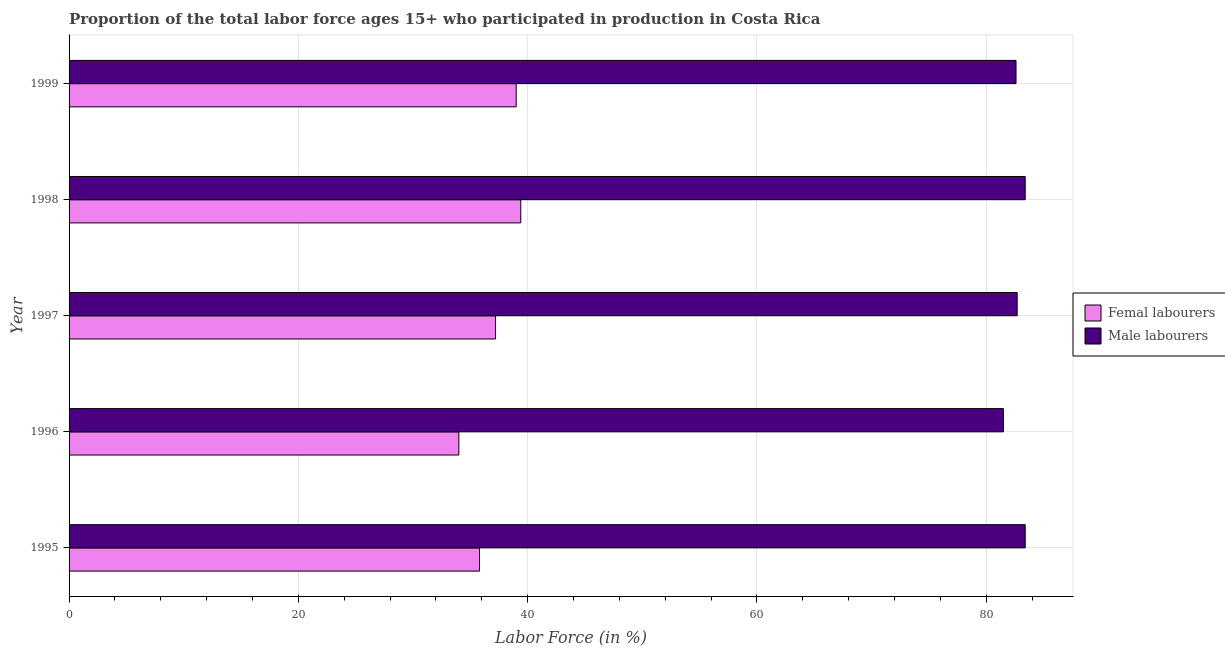How many groups of bars are there?
Make the answer very short. 5. Are the number of bars per tick equal to the number of legend labels?
Ensure brevity in your answer.  Yes. Are the number of bars on each tick of the Y-axis equal?
Keep it short and to the point. Yes. How many bars are there on the 5th tick from the top?
Give a very brief answer. 2. How many bars are there on the 5th tick from the bottom?
Ensure brevity in your answer.  2. What is the label of the 2nd group of bars from the top?
Your response must be concise. 1998. What is the percentage of male labour force in 1998?
Provide a succinct answer. 83.4. Across all years, what is the maximum percentage of female labor force?
Offer a terse response. 39.4. Across all years, what is the minimum percentage of female labor force?
Offer a terse response. 34. In which year was the percentage of female labor force maximum?
Ensure brevity in your answer.  1998. What is the total percentage of male labour force in the graph?
Provide a short and direct response. 413.6. What is the difference between the percentage of female labor force in 1995 and the percentage of male labour force in 1998?
Offer a very short reply. -47.6. What is the average percentage of male labour force per year?
Keep it short and to the point. 82.72. In the year 1996, what is the difference between the percentage of female labor force and percentage of male labour force?
Give a very brief answer. -47.5. What is the ratio of the percentage of female labor force in 1996 to that in 1998?
Make the answer very short. 0.86. Is the percentage of female labor force in 1996 less than that in 1999?
Keep it short and to the point. Yes. What does the 1st bar from the top in 1999 represents?
Your response must be concise. Male labourers. What does the 1st bar from the bottom in 1997 represents?
Provide a short and direct response. Femal labourers. Are all the bars in the graph horizontal?
Offer a terse response. Yes. Does the graph contain grids?
Provide a short and direct response. Yes. How many legend labels are there?
Keep it short and to the point. 2. How are the legend labels stacked?
Make the answer very short. Vertical. What is the title of the graph?
Make the answer very short. Proportion of the total labor force ages 15+ who participated in production in Costa Rica. Does "Automatic Teller Machines" appear as one of the legend labels in the graph?
Provide a succinct answer. No. What is the label or title of the X-axis?
Your response must be concise. Labor Force (in %). What is the label or title of the Y-axis?
Give a very brief answer. Year. What is the Labor Force (in %) in Femal labourers in 1995?
Your answer should be compact. 35.8. What is the Labor Force (in %) of Male labourers in 1995?
Make the answer very short. 83.4. What is the Labor Force (in %) in Male labourers in 1996?
Provide a succinct answer. 81.5. What is the Labor Force (in %) of Femal labourers in 1997?
Your response must be concise. 37.2. What is the Labor Force (in %) of Male labourers in 1997?
Provide a short and direct response. 82.7. What is the Labor Force (in %) of Femal labourers in 1998?
Make the answer very short. 39.4. What is the Labor Force (in %) in Male labourers in 1998?
Offer a very short reply. 83.4. What is the Labor Force (in %) in Femal labourers in 1999?
Provide a succinct answer. 39. What is the Labor Force (in %) of Male labourers in 1999?
Give a very brief answer. 82.6. Across all years, what is the maximum Labor Force (in %) in Femal labourers?
Provide a short and direct response. 39.4. Across all years, what is the maximum Labor Force (in %) of Male labourers?
Your response must be concise. 83.4. Across all years, what is the minimum Labor Force (in %) of Male labourers?
Offer a terse response. 81.5. What is the total Labor Force (in %) of Femal labourers in the graph?
Offer a very short reply. 185.4. What is the total Labor Force (in %) in Male labourers in the graph?
Make the answer very short. 413.6. What is the difference between the Labor Force (in %) of Femal labourers in 1995 and that in 1996?
Offer a terse response. 1.8. What is the difference between the Labor Force (in %) of Male labourers in 1995 and that in 1996?
Your response must be concise. 1.9. What is the difference between the Labor Force (in %) of Femal labourers in 1995 and that in 1999?
Make the answer very short. -3.2. What is the difference between the Labor Force (in %) of Femal labourers in 1996 and that in 1998?
Your answer should be compact. -5.4. What is the difference between the Labor Force (in %) in Male labourers in 1996 and that in 1998?
Offer a terse response. -1.9. What is the difference between the Labor Force (in %) of Femal labourers in 1996 and that in 1999?
Keep it short and to the point. -5. What is the difference between the Labor Force (in %) in Male labourers in 1997 and that in 1998?
Ensure brevity in your answer.  -0.7. What is the difference between the Labor Force (in %) in Male labourers in 1997 and that in 1999?
Provide a succinct answer. 0.1. What is the difference between the Labor Force (in %) of Femal labourers in 1998 and that in 1999?
Ensure brevity in your answer.  0.4. What is the difference between the Labor Force (in %) of Male labourers in 1998 and that in 1999?
Your answer should be compact. 0.8. What is the difference between the Labor Force (in %) of Femal labourers in 1995 and the Labor Force (in %) of Male labourers in 1996?
Your response must be concise. -45.7. What is the difference between the Labor Force (in %) of Femal labourers in 1995 and the Labor Force (in %) of Male labourers in 1997?
Your answer should be compact. -46.9. What is the difference between the Labor Force (in %) of Femal labourers in 1995 and the Labor Force (in %) of Male labourers in 1998?
Offer a very short reply. -47.6. What is the difference between the Labor Force (in %) of Femal labourers in 1995 and the Labor Force (in %) of Male labourers in 1999?
Ensure brevity in your answer.  -46.8. What is the difference between the Labor Force (in %) of Femal labourers in 1996 and the Labor Force (in %) of Male labourers in 1997?
Make the answer very short. -48.7. What is the difference between the Labor Force (in %) of Femal labourers in 1996 and the Labor Force (in %) of Male labourers in 1998?
Make the answer very short. -49.4. What is the difference between the Labor Force (in %) in Femal labourers in 1996 and the Labor Force (in %) in Male labourers in 1999?
Provide a succinct answer. -48.6. What is the difference between the Labor Force (in %) in Femal labourers in 1997 and the Labor Force (in %) in Male labourers in 1998?
Offer a very short reply. -46.2. What is the difference between the Labor Force (in %) in Femal labourers in 1997 and the Labor Force (in %) in Male labourers in 1999?
Keep it short and to the point. -45.4. What is the difference between the Labor Force (in %) in Femal labourers in 1998 and the Labor Force (in %) in Male labourers in 1999?
Keep it short and to the point. -43.2. What is the average Labor Force (in %) of Femal labourers per year?
Make the answer very short. 37.08. What is the average Labor Force (in %) in Male labourers per year?
Your response must be concise. 82.72. In the year 1995, what is the difference between the Labor Force (in %) of Femal labourers and Labor Force (in %) of Male labourers?
Offer a very short reply. -47.6. In the year 1996, what is the difference between the Labor Force (in %) in Femal labourers and Labor Force (in %) in Male labourers?
Ensure brevity in your answer.  -47.5. In the year 1997, what is the difference between the Labor Force (in %) in Femal labourers and Labor Force (in %) in Male labourers?
Offer a terse response. -45.5. In the year 1998, what is the difference between the Labor Force (in %) in Femal labourers and Labor Force (in %) in Male labourers?
Your answer should be compact. -44. In the year 1999, what is the difference between the Labor Force (in %) of Femal labourers and Labor Force (in %) of Male labourers?
Make the answer very short. -43.6. What is the ratio of the Labor Force (in %) in Femal labourers in 1995 to that in 1996?
Keep it short and to the point. 1.05. What is the ratio of the Labor Force (in %) of Male labourers in 1995 to that in 1996?
Offer a very short reply. 1.02. What is the ratio of the Labor Force (in %) in Femal labourers in 1995 to that in 1997?
Your answer should be very brief. 0.96. What is the ratio of the Labor Force (in %) in Male labourers in 1995 to that in 1997?
Your response must be concise. 1.01. What is the ratio of the Labor Force (in %) in Femal labourers in 1995 to that in 1998?
Offer a terse response. 0.91. What is the ratio of the Labor Force (in %) in Femal labourers in 1995 to that in 1999?
Offer a terse response. 0.92. What is the ratio of the Labor Force (in %) of Male labourers in 1995 to that in 1999?
Offer a terse response. 1.01. What is the ratio of the Labor Force (in %) of Femal labourers in 1996 to that in 1997?
Offer a terse response. 0.91. What is the ratio of the Labor Force (in %) of Male labourers in 1996 to that in 1997?
Keep it short and to the point. 0.99. What is the ratio of the Labor Force (in %) of Femal labourers in 1996 to that in 1998?
Your answer should be very brief. 0.86. What is the ratio of the Labor Force (in %) in Male labourers in 1996 to that in 1998?
Give a very brief answer. 0.98. What is the ratio of the Labor Force (in %) of Femal labourers in 1996 to that in 1999?
Keep it short and to the point. 0.87. What is the ratio of the Labor Force (in %) in Male labourers in 1996 to that in 1999?
Ensure brevity in your answer.  0.99. What is the ratio of the Labor Force (in %) in Femal labourers in 1997 to that in 1998?
Make the answer very short. 0.94. What is the ratio of the Labor Force (in %) of Femal labourers in 1997 to that in 1999?
Your answer should be very brief. 0.95. What is the ratio of the Labor Force (in %) of Femal labourers in 1998 to that in 1999?
Give a very brief answer. 1.01. What is the ratio of the Labor Force (in %) in Male labourers in 1998 to that in 1999?
Offer a terse response. 1.01. What is the difference between the highest and the second highest Labor Force (in %) of Male labourers?
Give a very brief answer. 0. What is the difference between the highest and the lowest Labor Force (in %) of Femal labourers?
Make the answer very short. 5.4. 